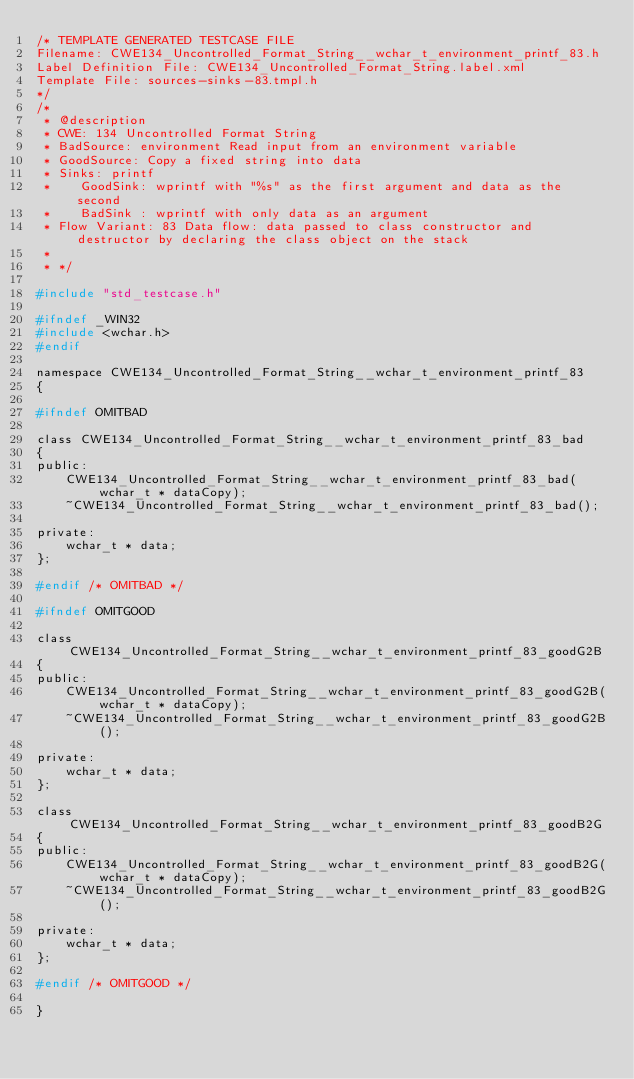Convert code to text. <code><loc_0><loc_0><loc_500><loc_500><_C_>/* TEMPLATE GENERATED TESTCASE FILE
Filename: CWE134_Uncontrolled_Format_String__wchar_t_environment_printf_83.h
Label Definition File: CWE134_Uncontrolled_Format_String.label.xml
Template File: sources-sinks-83.tmpl.h
*/
/*
 * @description
 * CWE: 134 Uncontrolled Format String
 * BadSource: environment Read input from an environment variable
 * GoodSource: Copy a fixed string into data
 * Sinks: printf
 *    GoodSink: wprintf with "%s" as the first argument and data as the second
 *    BadSink : wprintf with only data as an argument
 * Flow Variant: 83 Data flow: data passed to class constructor and destructor by declaring the class object on the stack
 *
 * */

#include "std_testcase.h"

#ifndef _WIN32
#include <wchar.h>
#endif

namespace CWE134_Uncontrolled_Format_String__wchar_t_environment_printf_83
{

#ifndef OMITBAD

class CWE134_Uncontrolled_Format_String__wchar_t_environment_printf_83_bad
{
public:
    CWE134_Uncontrolled_Format_String__wchar_t_environment_printf_83_bad(wchar_t * dataCopy);
    ~CWE134_Uncontrolled_Format_String__wchar_t_environment_printf_83_bad();

private:
    wchar_t * data;
};

#endif /* OMITBAD */

#ifndef OMITGOOD

class CWE134_Uncontrolled_Format_String__wchar_t_environment_printf_83_goodG2B
{
public:
    CWE134_Uncontrolled_Format_String__wchar_t_environment_printf_83_goodG2B(wchar_t * dataCopy);
    ~CWE134_Uncontrolled_Format_String__wchar_t_environment_printf_83_goodG2B();

private:
    wchar_t * data;
};

class CWE134_Uncontrolled_Format_String__wchar_t_environment_printf_83_goodB2G
{
public:
    CWE134_Uncontrolled_Format_String__wchar_t_environment_printf_83_goodB2G(wchar_t * dataCopy);
    ~CWE134_Uncontrolled_Format_String__wchar_t_environment_printf_83_goodB2G();

private:
    wchar_t * data;
};

#endif /* OMITGOOD */

}
</code> 